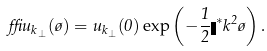<formula> <loc_0><loc_0><loc_500><loc_500>\delta u _ { k _ { \perp } } ( \tau ) = u _ { k _ { \perp } } ( 0 ) \exp \left ( - \frac { 1 } { 2 } \eta ^ { * } k ^ { 2 } \tau \right ) .</formula> 